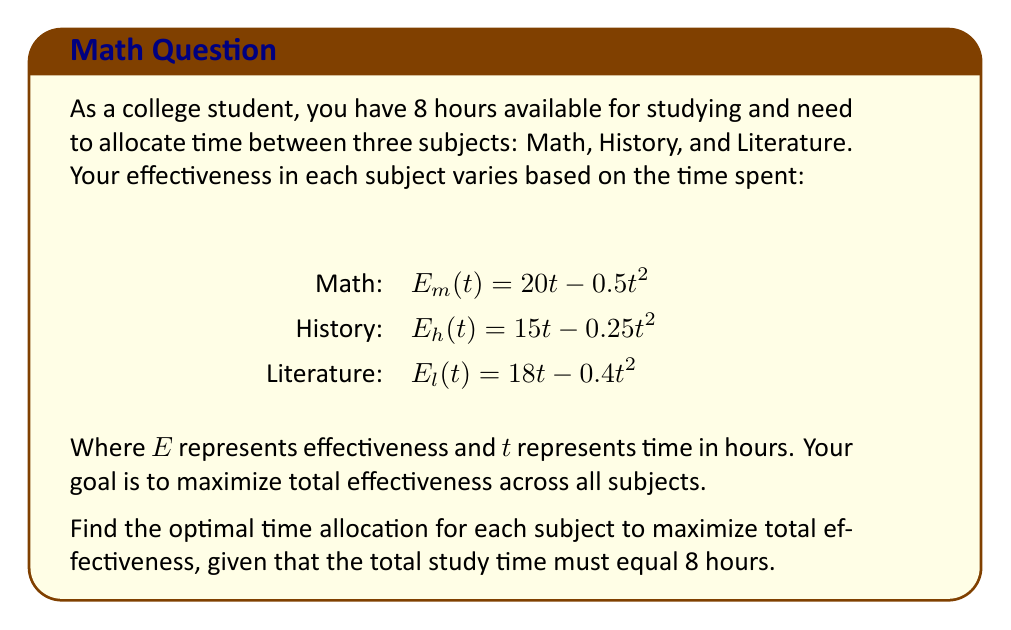Can you answer this question? To solve this optimization problem, we'll use the method of Lagrange multipliers:

1) Let's define our objective function:
   $f(t_m, t_h, t_l) = E_m(t_m) + E_h(t_h) + E_l(t_l)$
   $= (20t_m - 0.5t_m^2) + (15t_h - 0.25t_h^2) + (18t_l - 0.4t_l^2)$

2) Our constraint is:
   $g(t_m, t_h, t_l) = t_m + t_h + t_l - 8 = 0$

3) We form the Lagrangian:
   $L(t_m, t_h, t_l, \lambda) = f(t_m, t_h, t_l) - \lambda g(t_m, t_h, t_l)$

4) We take partial derivatives and set them to zero:
   $\frac{\partial L}{\partial t_m} = 20 - t_m - \lambda = 0$
   $\frac{\partial L}{\partial t_h} = 15 - 0.5t_h - \lambda = 0$
   $\frac{\partial L}{\partial t_l} = 18 - 0.8t_l - \lambda = 0$
   $\frac{\partial L}{\partial \lambda} = t_m + t_h + t_l - 8 = 0$

5) From these equations:
   $t_m = 20 - \lambda$
   $t_h = 30 - 2\lambda$
   $t_l = 22.5 - 1.25\lambda$

6) Substituting into the constraint equation:
   $(20 - \lambda) + (30 - 2\lambda) + (22.5 - 1.25\lambda) = 8$
   $72.5 - 4.25\lambda = 8$
   $64.5 = 4.25\lambda$
   $\lambda = 15.18$

7) Substituting back:
   $t_m = 20 - 15.18 = 4.82$ hours
   $t_h = 30 - 2(15.18) = -0.36$ hours (invalid)
   $t_l = 22.5 - 1.25(15.18) = 3.53$ hours

8) Since we got a negative value for History, we need to set $t_h = 0$ and resolve:
   $t_m + t_l = 8$
   $20 - \lambda = t_m$
   $22.5 - 1.25\lambda = t_l$
   
   Solving this system:
   $t_m = 4.44$ hours
   $t_l = 3.56$ hours
   $t_h = 0$ hours
Answer: The optimal time allocation is:
Math: 4.44 hours
Literature: 3.56 hours
History: 0 hours 